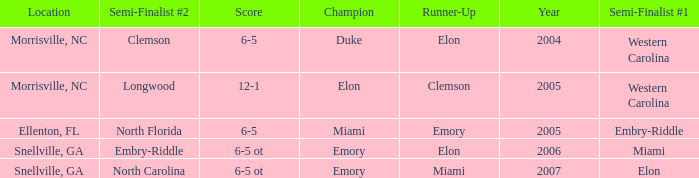When Embry-Riddle made it to the first semi finalist slot, list all the runners up. Emory. 